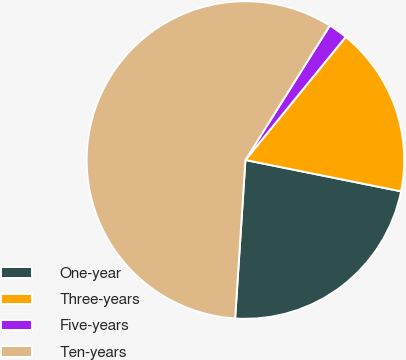Convert chart to OTSL. <chart><loc_0><loc_0><loc_500><loc_500><pie_chart><fcel>One-year<fcel>Three-years<fcel>Five-years<fcel>Ten-years<nl><fcel>22.87%<fcel>17.28%<fcel>1.96%<fcel>57.89%<nl></chart> 